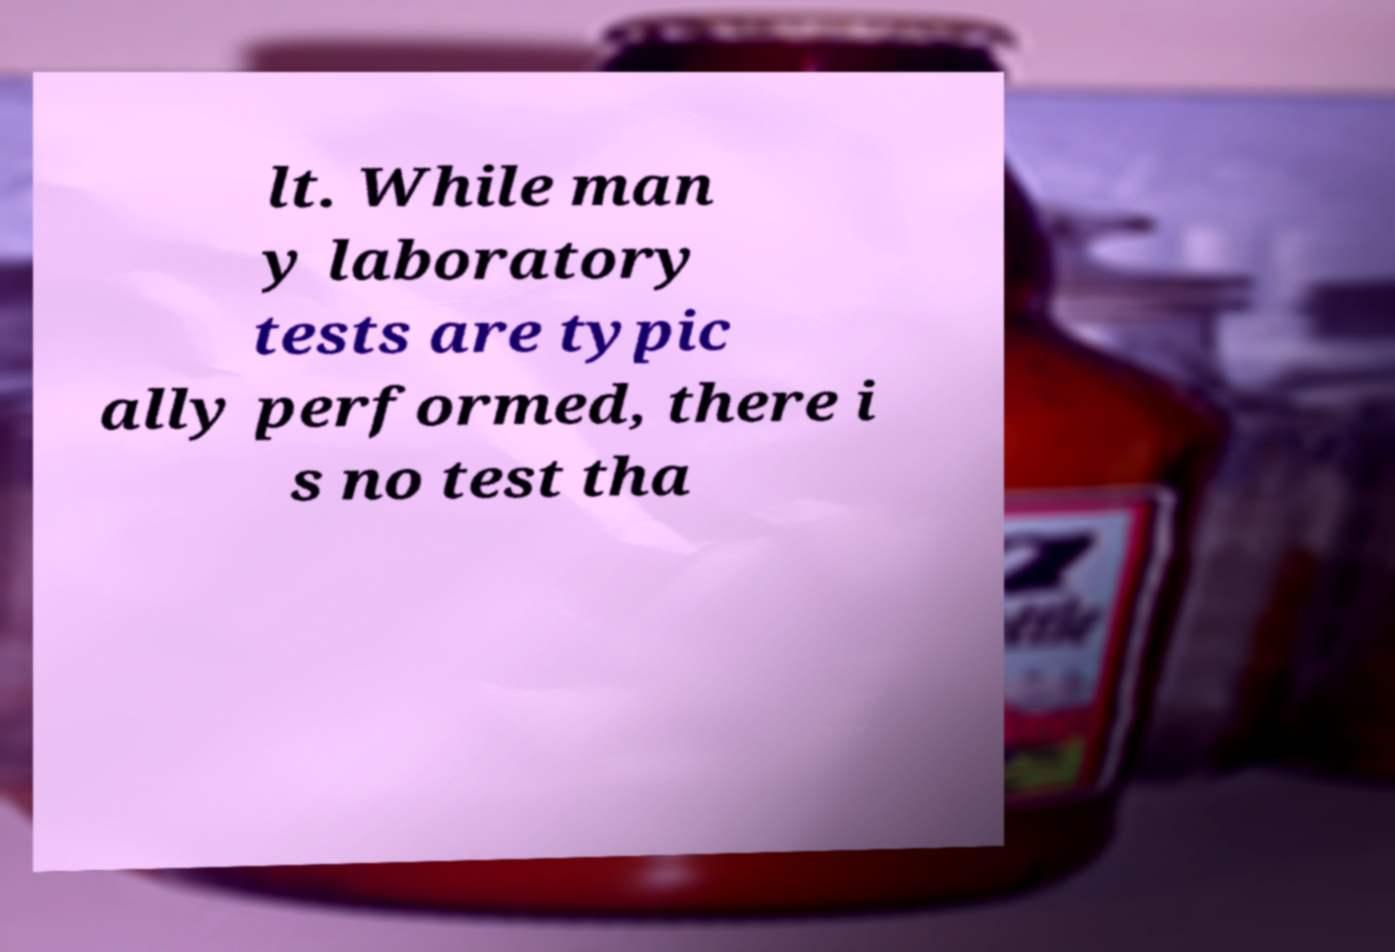Can you accurately transcribe the text from the provided image for me? lt. While man y laboratory tests are typic ally performed, there i s no test tha 